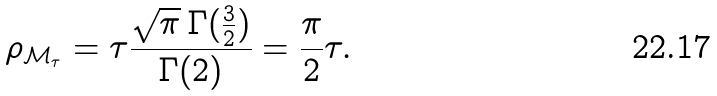<formula> <loc_0><loc_0><loc_500><loc_500>\rho _ { \mathcal { M } _ { \tau } } = \tau \frac { \sqrt { \pi } \, \Gamma ( \frac { 3 } { 2 } ) } { \Gamma ( 2 ) } = \frac { \pi } { 2 } \tau .</formula> 